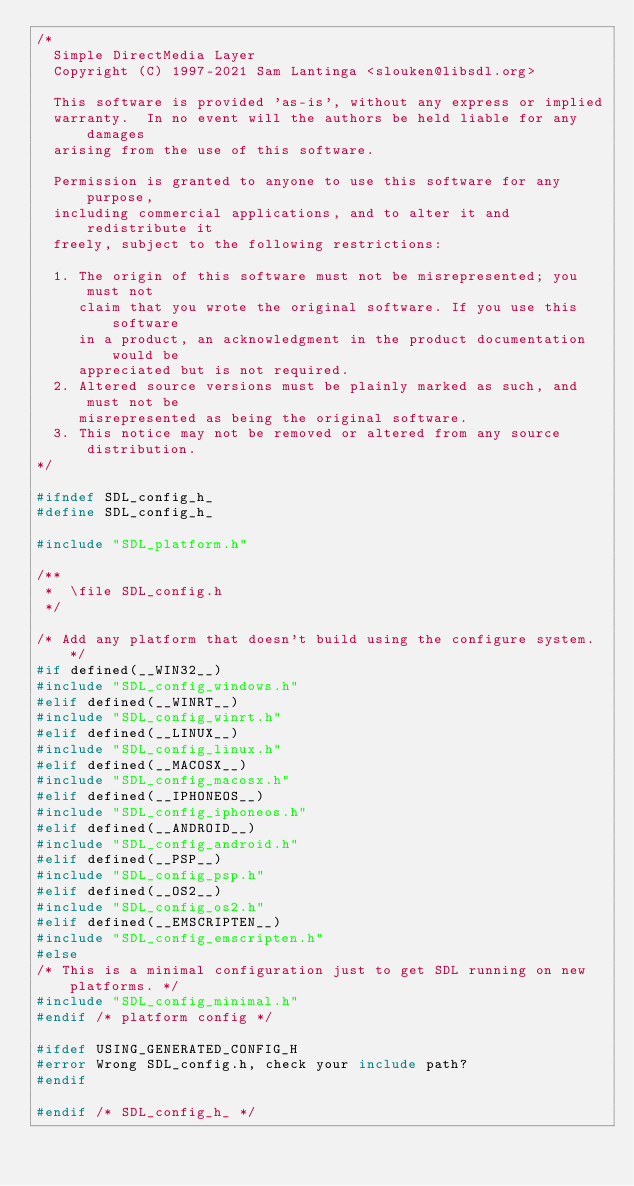<code> <loc_0><loc_0><loc_500><loc_500><_C_>/*
  Simple DirectMedia Layer
  Copyright (C) 1997-2021 Sam Lantinga <slouken@libsdl.org>

  This software is provided 'as-is', without any express or implied
  warranty.  In no event will the authors be held liable for any damages
  arising from the use of this software.

  Permission is granted to anyone to use this software for any purpose,
  including commercial applications, and to alter it and redistribute it
  freely, subject to the following restrictions:

  1. The origin of this software must not be misrepresented; you must not
     claim that you wrote the original software. If you use this software
     in a product, an acknowledgment in the product documentation would be
     appreciated but is not required.
  2. Altered source versions must be plainly marked as such, and must not be
     misrepresented as being the original software.
  3. This notice may not be removed or altered from any source distribution.
*/

#ifndef SDL_config_h_
#define SDL_config_h_

#include "SDL_platform.h"

/**
 *  \file SDL_config.h
 */

/* Add any platform that doesn't build using the configure system. */
#if defined(__WIN32__)
#include "SDL_config_windows.h"
#elif defined(__WINRT__)
#include "SDL_config_winrt.h"
#elif defined(__LINUX__)
#include "SDL_config_linux.h"
#elif defined(__MACOSX__)
#include "SDL_config_macosx.h"
#elif defined(__IPHONEOS__)
#include "SDL_config_iphoneos.h"
#elif defined(__ANDROID__)
#include "SDL_config_android.h"
#elif defined(__PSP__)
#include "SDL_config_psp.h"
#elif defined(__OS2__)
#include "SDL_config_os2.h"
#elif defined(__EMSCRIPTEN__)
#include "SDL_config_emscripten.h"
#else
/* This is a minimal configuration just to get SDL running on new platforms. */
#include "SDL_config_minimal.h"
#endif /* platform config */

#ifdef USING_GENERATED_CONFIG_H
#error Wrong SDL_config.h, check your include path?
#endif

#endif /* SDL_config_h_ */
</code> 